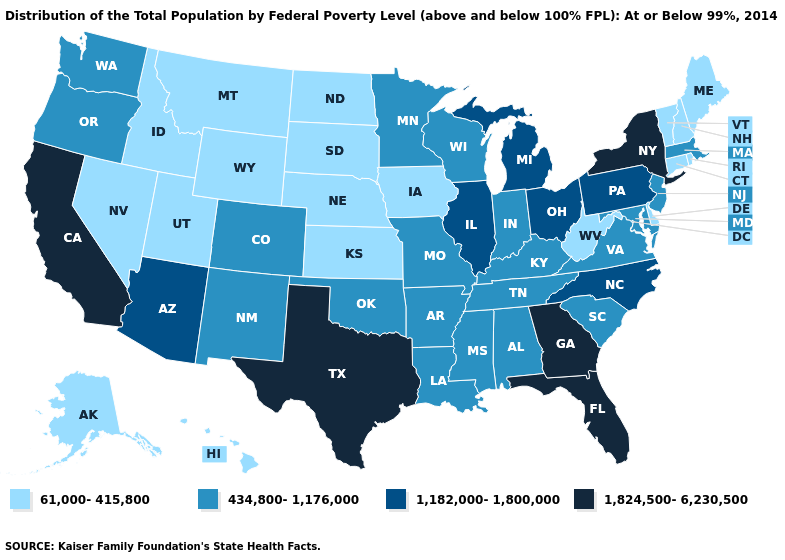What is the value of Indiana?
Short answer required. 434,800-1,176,000. What is the value of Wisconsin?
Concise answer only. 434,800-1,176,000. What is the value of South Carolina?
Answer briefly. 434,800-1,176,000. What is the value of Minnesota?
Give a very brief answer. 434,800-1,176,000. Which states have the highest value in the USA?
Concise answer only. California, Florida, Georgia, New York, Texas. Name the states that have a value in the range 1,824,500-6,230,500?
Short answer required. California, Florida, Georgia, New York, Texas. Is the legend a continuous bar?
Give a very brief answer. No. Does Florida have the highest value in the South?
Concise answer only. Yes. Does Delaware have the lowest value in the USA?
Give a very brief answer. Yes. Name the states that have a value in the range 1,182,000-1,800,000?
Be succinct. Arizona, Illinois, Michigan, North Carolina, Ohio, Pennsylvania. Does Montana have the lowest value in the USA?
Short answer required. Yes. What is the value of Utah?
Concise answer only. 61,000-415,800. Name the states that have a value in the range 61,000-415,800?
Keep it brief. Alaska, Connecticut, Delaware, Hawaii, Idaho, Iowa, Kansas, Maine, Montana, Nebraska, Nevada, New Hampshire, North Dakota, Rhode Island, South Dakota, Utah, Vermont, West Virginia, Wyoming. What is the value of New Hampshire?
Write a very short answer. 61,000-415,800. What is the value of Iowa?
Be succinct. 61,000-415,800. 